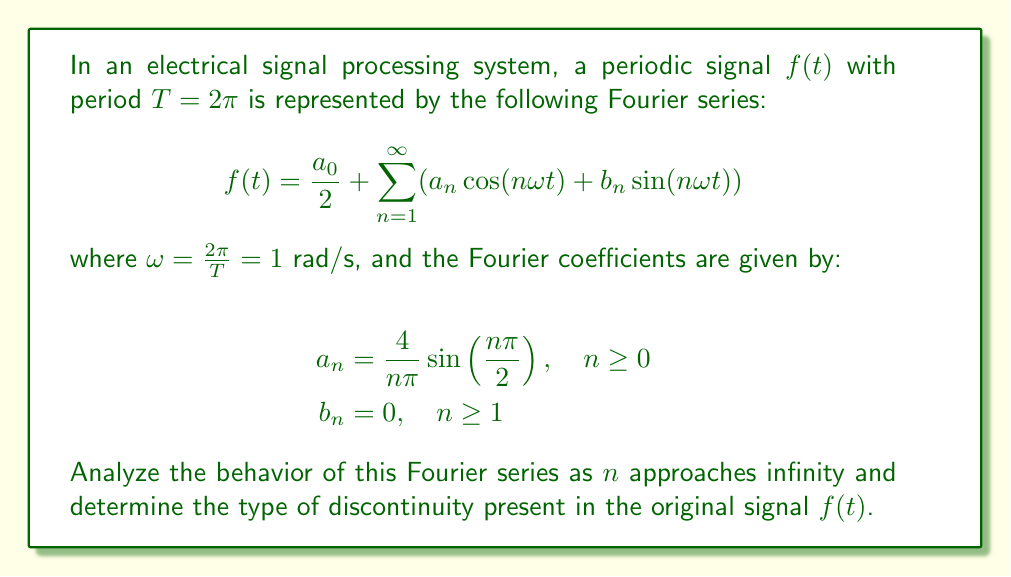Can you solve this math problem? Let's analyze this Fourier series step by step:

1) First, we observe that all $b_n$ coefficients are zero, which means the series consists only of cosine terms.

2) The $a_n$ coefficients are given by:

   $$a_n = \frac{4}{n\pi} \sin\left(\frac{n\pi}{2}\right)$$

3) Let's examine the behavior of $a_n$ for different values of $n$:

   - When $n$ is even: $\sin(\frac{n\pi}{2}) = 0$, so $a_n = 0$
   - When $n$ is odd: $\sin(\frac{n\pi}{2}) = \pm 1$, alternating for each odd $n$

4) For odd $n$, we can simplify $a_n$ to:

   $$a_n = \frac{4}{n\pi} \cdot (-1)^{\frac{n-1}{2}}$$

5) As $n$ approaches infinity, the magnitude of $a_n$ decreases as $\frac{1}{n}$. This is a relatively slow decay, indicating a discontinuity in the original signal.

6) The alternating signs of $a_n$ for odd $n$ and the $\frac{1}{n}$ decay are characteristic of a jump discontinuity in the original signal.

7) The Fourier series can be rewritten as:

   $$f(t) = \frac{a_0}{2} + \sum_{k=0}^{\infty} \frac{4}{(2k+1)\pi} \cdot (-1)^k \cos((2k+1)t)$$

8) This form of the Fourier series represents a square wave with a period of $2\pi$ and amplitude of 1.

9) The jump discontinuity occurs at $t = 0, \pi, 2\pi, ...$ where the signal abruptly changes from +1 to -1 or vice versa.

Therefore, the behavior of this Fourier series as $n$ approaches infinity indicates a jump discontinuity in the original signal $f(t)$, specifically representing a square wave.
Answer: Jump discontinuity (square wave) 